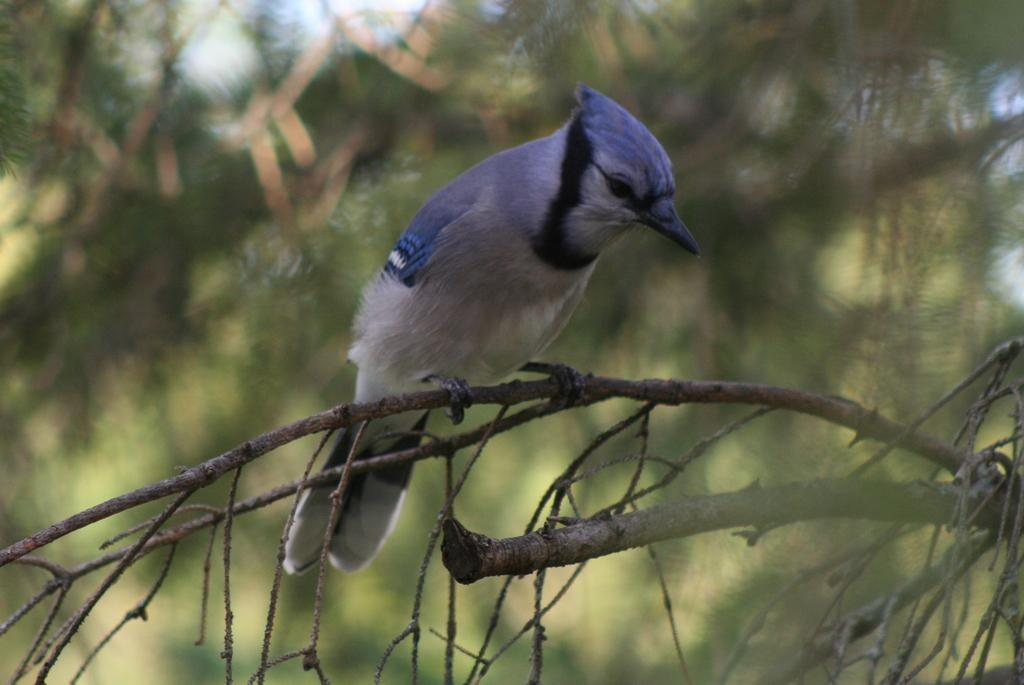What type of animal is in the image? There is a bird in the image. Where is the bird located? The bird is sitting on a stem. What can be observed about the background of the image? The background of the image is blurred. What part of the bird is covered by an expert in the image? There is no expert present in the image, and no part of the bird is covered by one. 